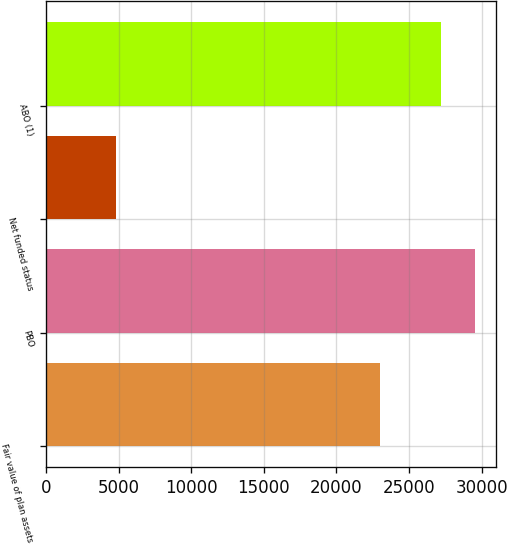Convert chart. <chart><loc_0><loc_0><loc_500><loc_500><bar_chart><fcel>Fair value of plan assets<fcel>PBO<fcel>Net funded status<fcel>ABO (1)<nl><fcel>23017<fcel>29537.7<fcel>4787<fcel>27236<nl></chart> 